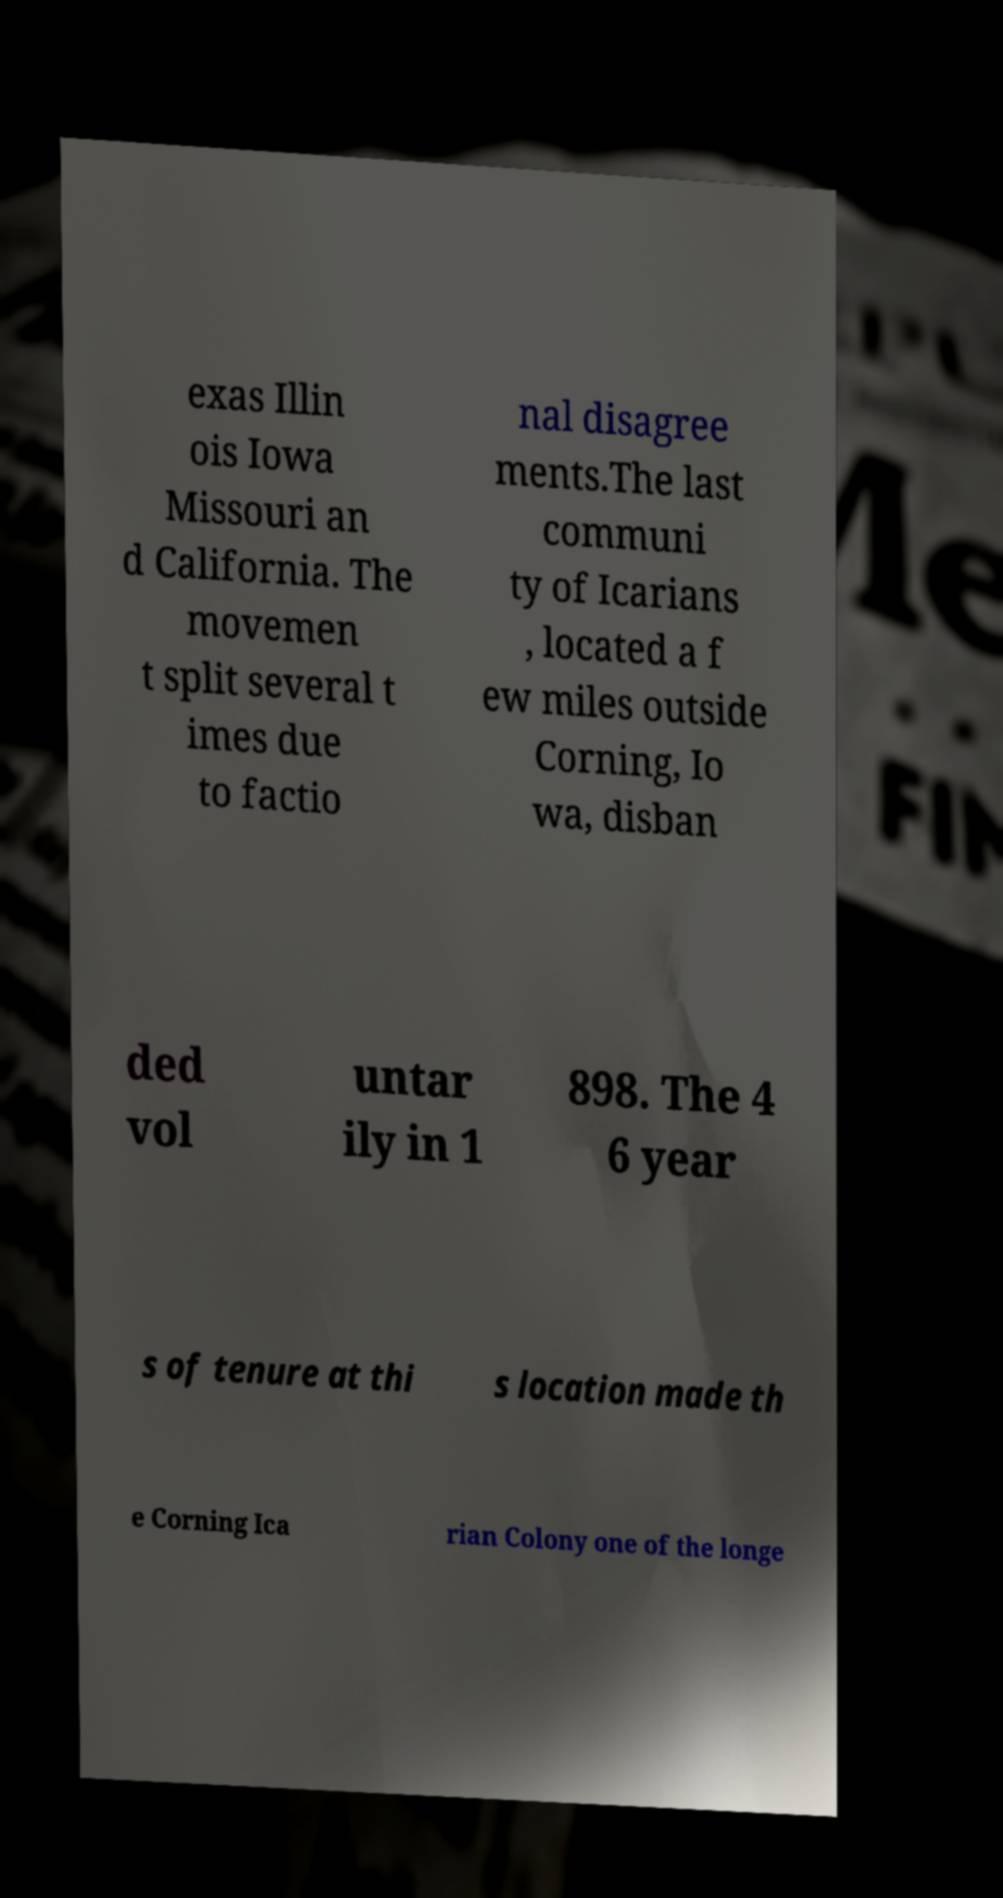I need the written content from this picture converted into text. Can you do that? exas Illin ois Iowa Missouri an d California. The movemen t split several t imes due to factio nal disagree ments.The last communi ty of Icarians , located a f ew miles outside Corning, Io wa, disban ded vol untar ily in 1 898. The 4 6 year s of tenure at thi s location made th e Corning Ica rian Colony one of the longe 